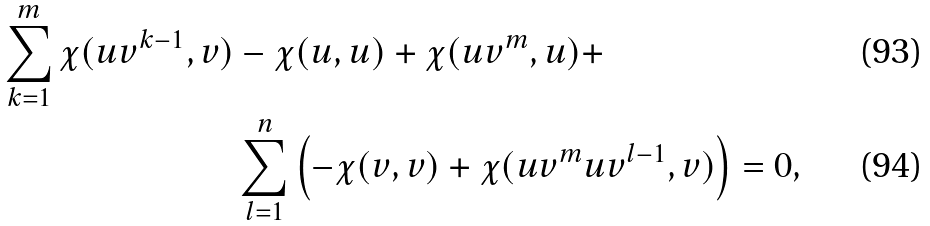Convert formula to latex. <formula><loc_0><loc_0><loc_500><loc_500>\sum _ { k = 1 } ^ { m } \chi ( u v ^ { k - 1 } , v ) & - \chi ( u , u ) + \chi ( u v ^ { m } , u ) + \\ & \sum _ { l = 1 } ^ { n } \left ( - \chi ( v , v ) + \chi ( u v ^ { m } u v ^ { l - 1 } , v ) \right ) = 0 ,</formula> 